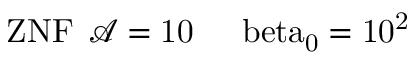Convert formula to latex. <formula><loc_0><loc_0><loc_500><loc_500>{ Z N F } \, \mathcal { A } = 1 0 \, \ b e t a _ { 0 } = 1 0 ^ { 2 }</formula> 